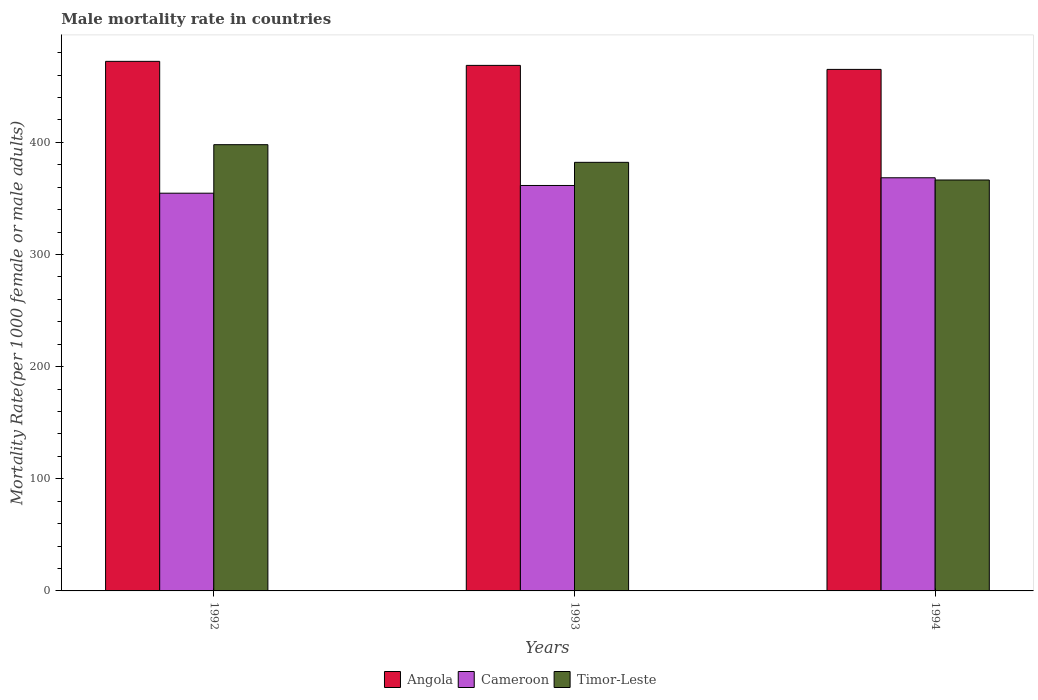How many bars are there on the 2nd tick from the right?
Offer a very short reply. 3. What is the label of the 3rd group of bars from the left?
Your response must be concise. 1994. What is the male mortality rate in Cameroon in 1993?
Keep it short and to the point. 361.54. Across all years, what is the maximum male mortality rate in Cameroon?
Your answer should be very brief. 368.42. Across all years, what is the minimum male mortality rate in Cameroon?
Your answer should be very brief. 354.66. In which year was the male mortality rate in Angola maximum?
Provide a succinct answer. 1992. What is the total male mortality rate in Angola in the graph?
Your answer should be compact. 1405.9. What is the difference between the male mortality rate in Angola in 1992 and that in 1993?
Your answer should be very brief. 3.59. What is the difference between the male mortality rate in Timor-Leste in 1992 and the male mortality rate in Angola in 1993?
Provide a succinct answer. -70.72. What is the average male mortality rate in Angola per year?
Keep it short and to the point. 468.63. In the year 1992, what is the difference between the male mortality rate in Cameroon and male mortality rate in Timor-Leste?
Provide a succinct answer. -43.26. In how many years, is the male mortality rate in Timor-Leste greater than 220?
Provide a succinct answer. 3. What is the ratio of the male mortality rate in Angola in 1992 to that in 1993?
Provide a short and direct response. 1.01. Is the difference between the male mortality rate in Cameroon in 1992 and 1994 greater than the difference between the male mortality rate in Timor-Leste in 1992 and 1994?
Give a very brief answer. No. What is the difference between the highest and the second highest male mortality rate in Timor-Leste?
Keep it short and to the point. 15.74. What is the difference between the highest and the lowest male mortality rate in Cameroon?
Ensure brevity in your answer.  13.76. What does the 3rd bar from the left in 1994 represents?
Your answer should be compact. Timor-Leste. What does the 1st bar from the right in 1994 represents?
Make the answer very short. Timor-Leste. How many bars are there?
Provide a succinct answer. 9. Are all the bars in the graph horizontal?
Keep it short and to the point. No. How many years are there in the graph?
Keep it short and to the point. 3. What is the difference between two consecutive major ticks on the Y-axis?
Your answer should be very brief. 100. Are the values on the major ticks of Y-axis written in scientific E-notation?
Provide a short and direct response. No. Where does the legend appear in the graph?
Offer a very short reply. Bottom center. What is the title of the graph?
Give a very brief answer. Male mortality rate in countries. Does "France" appear as one of the legend labels in the graph?
Provide a succinct answer. No. What is the label or title of the Y-axis?
Provide a succinct answer. Mortality Rate(per 1000 female or male adults). What is the Mortality Rate(per 1000 female or male adults) in Angola in 1992?
Offer a terse response. 472.23. What is the Mortality Rate(per 1000 female or male adults) in Cameroon in 1992?
Provide a short and direct response. 354.66. What is the Mortality Rate(per 1000 female or male adults) in Timor-Leste in 1992?
Provide a succinct answer. 397.92. What is the Mortality Rate(per 1000 female or male adults) of Angola in 1993?
Ensure brevity in your answer.  468.63. What is the Mortality Rate(per 1000 female or male adults) in Cameroon in 1993?
Offer a very short reply. 361.54. What is the Mortality Rate(per 1000 female or male adults) of Timor-Leste in 1993?
Ensure brevity in your answer.  382.18. What is the Mortality Rate(per 1000 female or male adults) in Angola in 1994?
Keep it short and to the point. 465.05. What is the Mortality Rate(per 1000 female or male adults) of Cameroon in 1994?
Your answer should be very brief. 368.42. What is the Mortality Rate(per 1000 female or male adults) in Timor-Leste in 1994?
Provide a succinct answer. 366.44. Across all years, what is the maximum Mortality Rate(per 1000 female or male adults) in Angola?
Provide a short and direct response. 472.23. Across all years, what is the maximum Mortality Rate(per 1000 female or male adults) in Cameroon?
Offer a very short reply. 368.42. Across all years, what is the maximum Mortality Rate(per 1000 female or male adults) in Timor-Leste?
Ensure brevity in your answer.  397.92. Across all years, what is the minimum Mortality Rate(per 1000 female or male adults) in Angola?
Your answer should be compact. 465.05. Across all years, what is the minimum Mortality Rate(per 1000 female or male adults) in Cameroon?
Ensure brevity in your answer.  354.66. Across all years, what is the minimum Mortality Rate(per 1000 female or male adults) of Timor-Leste?
Keep it short and to the point. 366.44. What is the total Mortality Rate(per 1000 female or male adults) in Angola in the graph?
Keep it short and to the point. 1405.9. What is the total Mortality Rate(per 1000 female or male adults) in Cameroon in the graph?
Your answer should be compact. 1084.61. What is the total Mortality Rate(per 1000 female or male adults) in Timor-Leste in the graph?
Offer a very short reply. 1146.53. What is the difference between the Mortality Rate(per 1000 female or male adults) in Angola in 1992 and that in 1993?
Your response must be concise. 3.59. What is the difference between the Mortality Rate(per 1000 female or male adults) of Cameroon in 1992 and that in 1993?
Offer a terse response. -6.88. What is the difference between the Mortality Rate(per 1000 female or male adults) in Timor-Leste in 1992 and that in 1993?
Your answer should be compact. 15.74. What is the difference between the Mortality Rate(per 1000 female or male adults) of Angola in 1992 and that in 1994?
Give a very brief answer. 7.18. What is the difference between the Mortality Rate(per 1000 female or male adults) of Cameroon in 1992 and that in 1994?
Ensure brevity in your answer.  -13.76. What is the difference between the Mortality Rate(per 1000 female or male adults) of Timor-Leste in 1992 and that in 1994?
Your answer should be compact. 31.48. What is the difference between the Mortality Rate(per 1000 female or male adults) of Angola in 1993 and that in 1994?
Keep it short and to the point. 3.59. What is the difference between the Mortality Rate(per 1000 female or male adults) in Cameroon in 1993 and that in 1994?
Offer a very short reply. -6.88. What is the difference between the Mortality Rate(per 1000 female or male adults) in Timor-Leste in 1993 and that in 1994?
Keep it short and to the point. 15.74. What is the difference between the Mortality Rate(per 1000 female or male adults) in Angola in 1992 and the Mortality Rate(per 1000 female or male adults) in Cameroon in 1993?
Offer a very short reply. 110.69. What is the difference between the Mortality Rate(per 1000 female or male adults) of Angola in 1992 and the Mortality Rate(per 1000 female or male adults) of Timor-Leste in 1993?
Keep it short and to the point. 90.05. What is the difference between the Mortality Rate(per 1000 female or male adults) in Cameroon in 1992 and the Mortality Rate(per 1000 female or male adults) in Timor-Leste in 1993?
Your response must be concise. -27.52. What is the difference between the Mortality Rate(per 1000 female or male adults) in Angola in 1992 and the Mortality Rate(per 1000 female or male adults) in Cameroon in 1994?
Ensure brevity in your answer.  103.81. What is the difference between the Mortality Rate(per 1000 female or male adults) in Angola in 1992 and the Mortality Rate(per 1000 female or male adults) in Timor-Leste in 1994?
Give a very brief answer. 105.79. What is the difference between the Mortality Rate(per 1000 female or male adults) in Cameroon in 1992 and the Mortality Rate(per 1000 female or male adults) in Timor-Leste in 1994?
Provide a succinct answer. -11.78. What is the difference between the Mortality Rate(per 1000 female or male adults) in Angola in 1993 and the Mortality Rate(per 1000 female or male adults) in Cameroon in 1994?
Ensure brevity in your answer.  100.22. What is the difference between the Mortality Rate(per 1000 female or male adults) of Angola in 1993 and the Mortality Rate(per 1000 female or male adults) of Timor-Leste in 1994?
Offer a very short reply. 102.2. What is the difference between the Mortality Rate(per 1000 female or male adults) of Cameroon in 1993 and the Mortality Rate(per 1000 female or male adults) of Timor-Leste in 1994?
Keep it short and to the point. -4.9. What is the average Mortality Rate(per 1000 female or male adults) of Angola per year?
Your answer should be compact. 468.63. What is the average Mortality Rate(per 1000 female or male adults) of Cameroon per year?
Offer a terse response. 361.54. What is the average Mortality Rate(per 1000 female or male adults) of Timor-Leste per year?
Offer a very short reply. 382.18. In the year 1992, what is the difference between the Mortality Rate(per 1000 female or male adults) of Angola and Mortality Rate(per 1000 female or male adults) of Cameroon?
Your answer should be compact. 117.57. In the year 1992, what is the difference between the Mortality Rate(per 1000 female or male adults) in Angola and Mortality Rate(per 1000 female or male adults) in Timor-Leste?
Keep it short and to the point. 74.31. In the year 1992, what is the difference between the Mortality Rate(per 1000 female or male adults) in Cameroon and Mortality Rate(per 1000 female or male adults) in Timor-Leste?
Your answer should be very brief. -43.26. In the year 1993, what is the difference between the Mortality Rate(per 1000 female or male adults) of Angola and Mortality Rate(per 1000 female or male adults) of Cameroon?
Offer a very short reply. 107.1. In the year 1993, what is the difference between the Mortality Rate(per 1000 female or male adults) of Angola and Mortality Rate(per 1000 female or male adults) of Timor-Leste?
Provide a succinct answer. 86.46. In the year 1993, what is the difference between the Mortality Rate(per 1000 female or male adults) of Cameroon and Mortality Rate(per 1000 female or male adults) of Timor-Leste?
Provide a short and direct response. -20.64. In the year 1994, what is the difference between the Mortality Rate(per 1000 female or male adults) of Angola and Mortality Rate(per 1000 female or male adults) of Cameroon?
Your response must be concise. 96.63. In the year 1994, what is the difference between the Mortality Rate(per 1000 female or male adults) in Angola and Mortality Rate(per 1000 female or male adults) in Timor-Leste?
Your response must be concise. 98.61. In the year 1994, what is the difference between the Mortality Rate(per 1000 female or male adults) in Cameroon and Mortality Rate(per 1000 female or male adults) in Timor-Leste?
Keep it short and to the point. 1.98. What is the ratio of the Mortality Rate(per 1000 female or male adults) of Angola in 1992 to that in 1993?
Keep it short and to the point. 1.01. What is the ratio of the Mortality Rate(per 1000 female or male adults) in Cameroon in 1992 to that in 1993?
Make the answer very short. 0.98. What is the ratio of the Mortality Rate(per 1000 female or male adults) in Timor-Leste in 1992 to that in 1993?
Provide a succinct answer. 1.04. What is the ratio of the Mortality Rate(per 1000 female or male adults) in Angola in 1992 to that in 1994?
Your response must be concise. 1.02. What is the ratio of the Mortality Rate(per 1000 female or male adults) of Cameroon in 1992 to that in 1994?
Your answer should be very brief. 0.96. What is the ratio of the Mortality Rate(per 1000 female or male adults) of Timor-Leste in 1992 to that in 1994?
Keep it short and to the point. 1.09. What is the ratio of the Mortality Rate(per 1000 female or male adults) in Angola in 1993 to that in 1994?
Your answer should be very brief. 1.01. What is the ratio of the Mortality Rate(per 1000 female or male adults) in Cameroon in 1993 to that in 1994?
Keep it short and to the point. 0.98. What is the ratio of the Mortality Rate(per 1000 female or male adults) of Timor-Leste in 1993 to that in 1994?
Offer a terse response. 1.04. What is the difference between the highest and the second highest Mortality Rate(per 1000 female or male adults) of Angola?
Provide a short and direct response. 3.59. What is the difference between the highest and the second highest Mortality Rate(per 1000 female or male adults) in Cameroon?
Keep it short and to the point. 6.88. What is the difference between the highest and the second highest Mortality Rate(per 1000 female or male adults) in Timor-Leste?
Provide a succinct answer. 15.74. What is the difference between the highest and the lowest Mortality Rate(per 1000 female or male adults) in Angola?
Offer a very short reply. 7.18. What is the difference between the highest and the lowest Mortality Rate(per 1000 female or male adults) in Cameroon?
Your answer should be very brief. 13.76. What is the difference between the highest and the lowest Mortality Rate(per 1000 female or male adults) of Timor-Leste?
Provide a succinct answer. 31.48. 